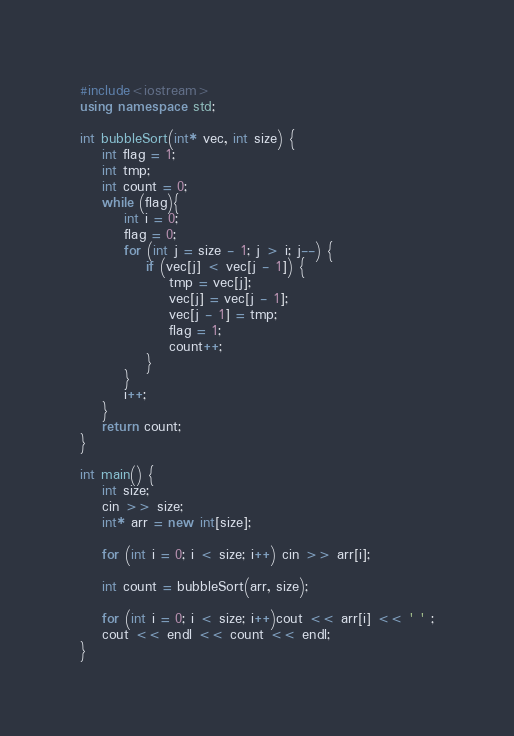Convert code to text. <code><loc_0><loc_0><loc_500><loc_500><_C++_>#include<iostream>
using namespace std;

int bubbleSort(int* vec, int size) {
	int flag = 1;
	int tmp;
	int count = 0;
	while (flag){
		int i = 0;
		flag = 0;
		for (int j = size - 1; j > i; j--) {
			if (vec[j] < vec[j - 1]) {
				tmp = vec[j];
				vec[j] = vec[j - 1];
				vec[j - 1] = tmp;
				flag = 1;
				count++;
			}
		}
		i++;
	}
	return count;
}

int main() {
	int size;
	cin >> size;
	int* arr = new int[size];

	for (int i = 0; i < size; i++) cin >> arr[i];

	int count = bubbleSort(arr, size);

	for (int i = 0; i < size; i++)cout << arr[i] << ' ' ;
	cout << endl << count << endl;
}</code> 